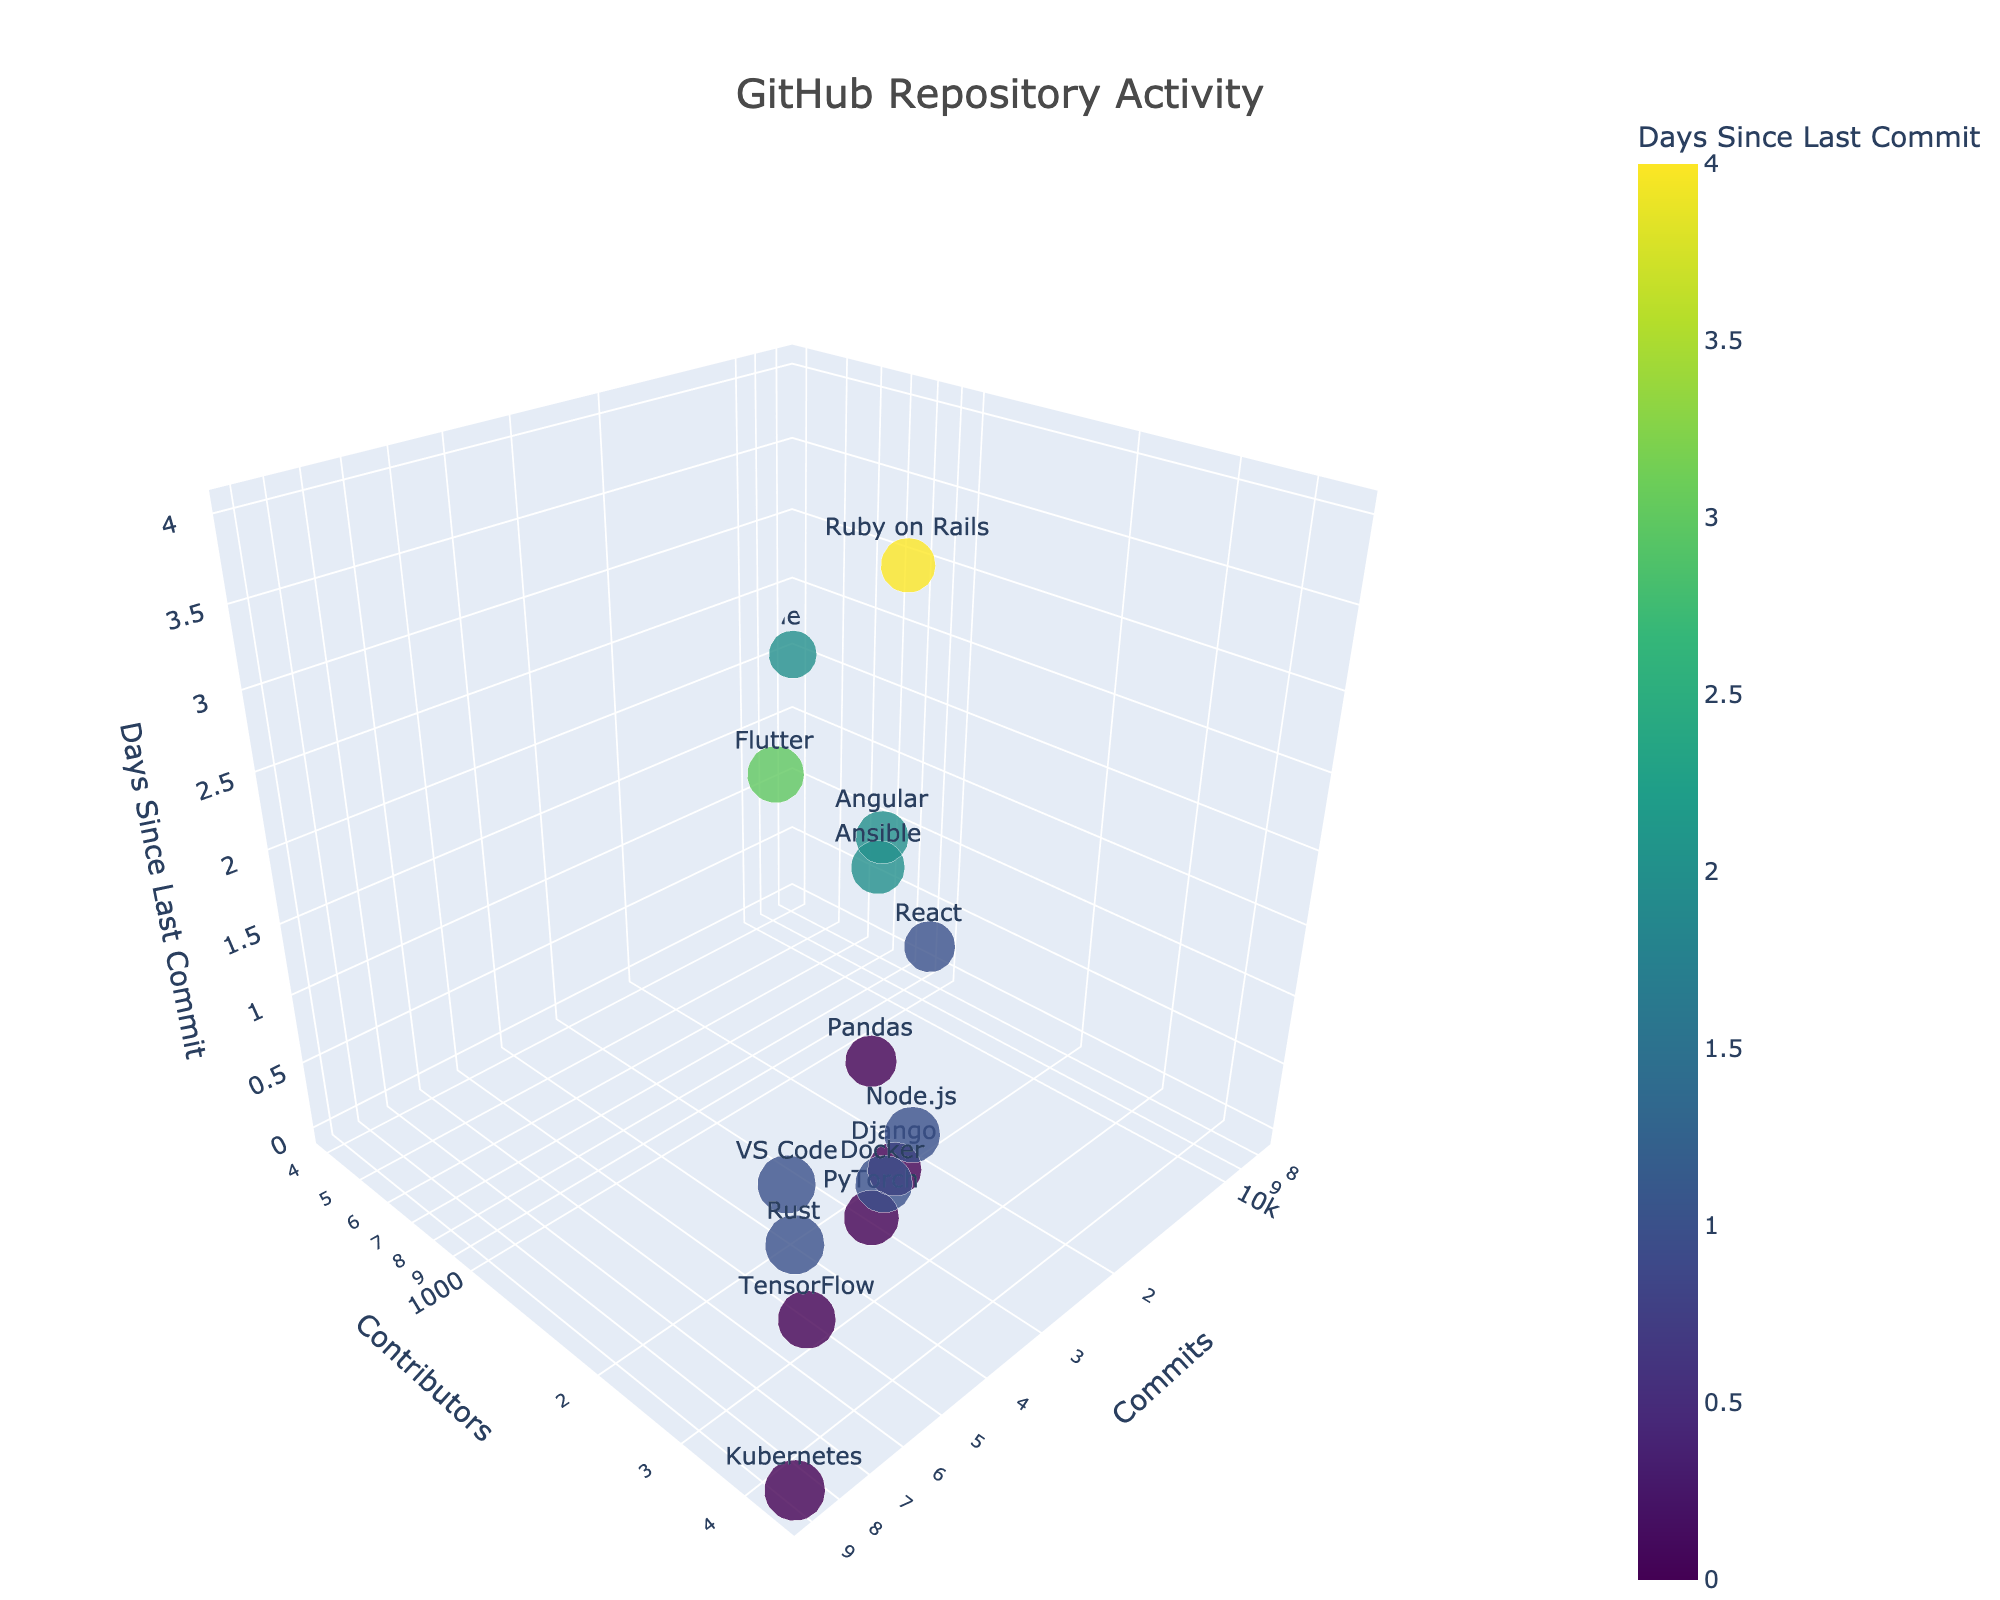what is the title of the figure? The title of the figure is displayed at the top of the plot and reads "GitHub Repository Activity".
Answer: GitHub Repository Activity how many open-source projects are shown in the plot? There are 15 data points in the plot, each representing a different open-source project.
Answer: 15 which project has the highest number of commits? By observing the x-axis values, "Kubernetes" has the highest number of commits, positioned farthest along the x-axis.
Answer: Kubernetes which project has the most contributors? "Kubernetes" is positioned farthest along the y-axis, indicating it has the most contributors.
Answer: Kubernetes which project has the most recent commit? Projects with 0 days since the last commit are the most recent. "TensorFlow", "Django", "Kubernetes", "PyTorch", and "Pandas" all have 0 days since the last commit.
Answer: TensorFlow, Django, Kubernetes, PyTorch, Pandas how many projects have had a commit within the last day or less? Counting the points with "0" and "1" values on the z-axis, there are 8 projects: React, TensorFlow, Django, Node.js, Kubernetes, Rust, PyTorch, and Docker.
Answer: 8 which project has the largest marker size, indicating the highest number of commits? Marker size is determined by the number of commits. The project "Kubernetes" has the largest marker size, indicating it has the highest number of commits.
Answer: Kubernetes what is the combined number of contributors for "React" and "Vue.js"? React has 1532 contributors and Vue.js has 398. Summing these gives 1532 + 398 = 1930.
Answer: 1930 which projects have more commits than "Angular"? Angular has 19876 commits. The projects with more commits are TensorFlow (52786), Django (24156), Node.js (35678), Kubernetes (89745), Flutter (42356), Rust (67890), PyTorch (31245), VS Code (56789), Docker (45678), and Ansible (23456).
Answer: TensorFlow, Django, Node.js, Kubernetes, Flutter, Rust, PyTorch, VS Code, Docker, Ansible how many projects have contributors less than 2000 but more than 1000? Projects in this range are "React" (1532), "Vue.js" (398), and "Angular" (1567). Summing these gives 3 projects. Note: Vue.js does not qualify as it has less than 1000 contributors. Only React and Angular qualify.
Answer: 2 